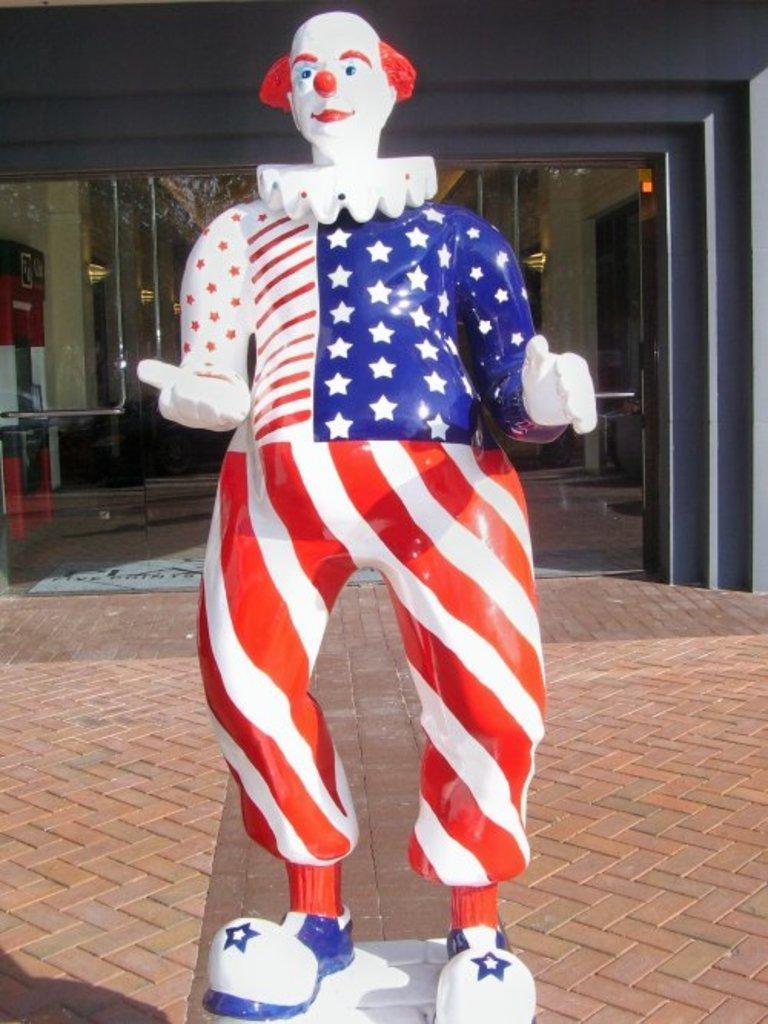Please provide a concise description of this image. In this image, we can see the statue of a clown. We can also see the ground. We can see the wall and some glass. We can also see some lights and an object on the left. 